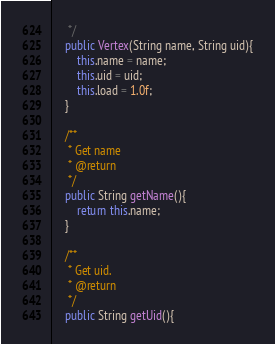<code> <loc_0><loc_0><loc_500><loc_500><_Java_>	 */
	public Vertex(String name, String uid){
		this.name = name;
		this.uid = uid;
		this.load = 1.0f;
	}
	
	/**
	 * Get name
	 * @return
	 */
	public String getName(){
		return this.name;
	}
	
	/**
	 * Get uid.
	 * @return
	 */
	public String getUid(){</code> 